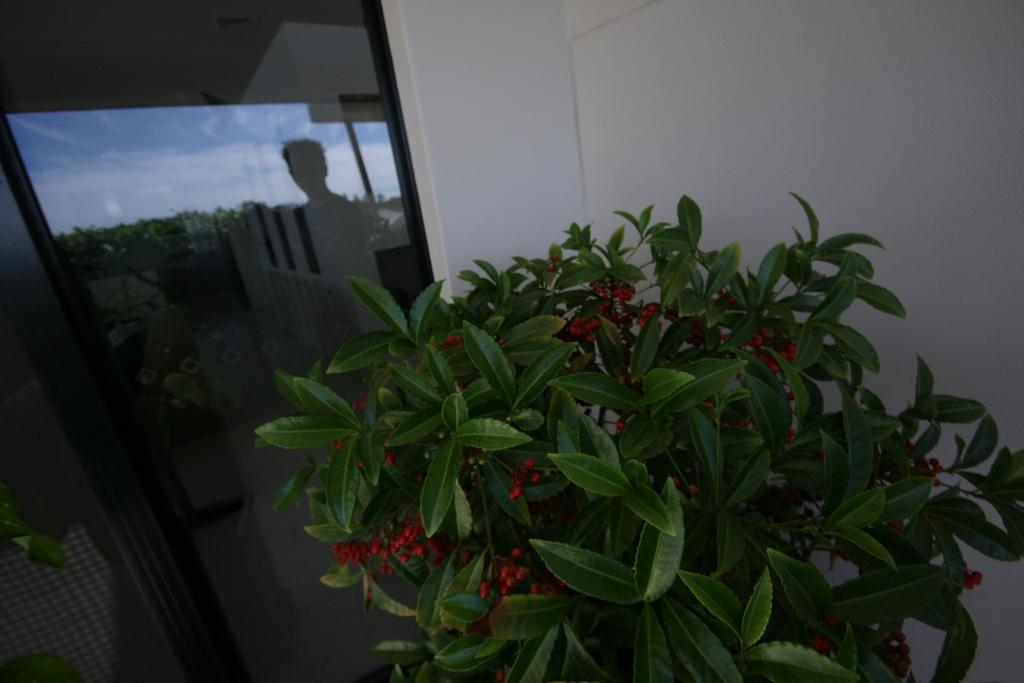What type of vegetation can be seen in the image? There is a plant and trees in the image. Can you describe the reflection on the window? There is a reflection of a person on the window. What is visible on the wall in the image? The wall is visible in the image. What part of the natural environment is visible in the image? The sky is visible in the image. What type of stone is used to build the tent in the image? There is no tent present in the image, so it is not possible to determine what type of stone might be used. 